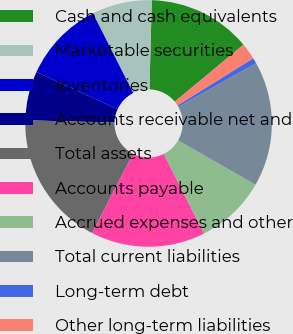Convert chart to OTSL. <chart><loc_0><loc_0><loc_500><loc_500><pie_chart><fcel>Cash and cash equivalents<fcel>Marketable securities<fcel>Inventories<fcel>Accounts receivable net and<fcel>Total assets<fcel>Accounts payable<fcel>Accrued expenses and other<fcel>Total current liabilities<fcel>Long-term debt<fcel>Other long-term liabilities<nl><fcel>13.56%<fcel>7.86%<fcel>10.71%<fcel>6.44%<fcel>17.84%<fcel>14.99%<fcel>9.29%<fcel>16.41%<fcel>0.74%<fcel>2.16%<nl></chart> 